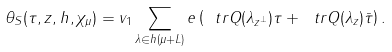<formula> <loc_0><loc_0><loc_500><loc_500>\theta _ { S } ( \tau , z , h , \chi _ { \mu } ) = v _ { 1 } \sum _ { \lambda \in h ( \mu + L ) } e \left ( \ t r Q ( \lambda _ { z ^ { \perp } } ) \tau + \ t r Q ( \lambda _ { z } ) \bar { \tau } \right ) .</formula> 